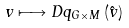<formula> <loc_0><loc_0><loc_500><loc_500>v \longmapsto D q _ { G \times M } \left ( \hat { v } \right )</formula> 